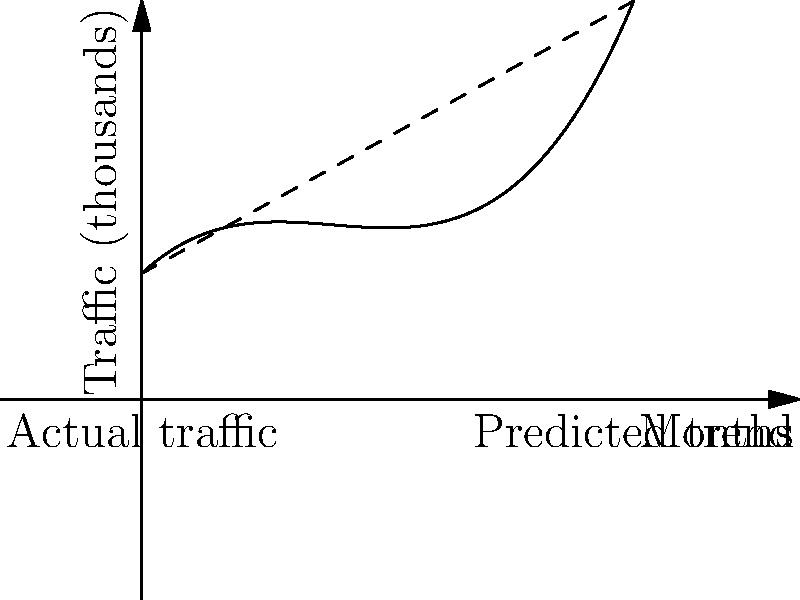Your e-commerce website's monthly traffic (in thousands) over the past year follows the polynomial function $f(x) = 0.5x^3 - 7x^2 + 30x + 100$, where $x$ represents the number of months since the start of the year. Based on this trend, what is the predicted traffic (rounded to the nearest thousand) for the 15th month? To solve this problem, we'll follow these steps:

1) We have the polynomial function: $f(x) = 0.5x^3 - 7x^2 + 30x + 100$

2) We need to calculate $f(15)$ as we want to predict the traffic for the 15th month.

3) Let's substitute $x = 15$ into the function:

   $f(15) = 0.5(15)^3 - 7(15)^2 + 30(15) + 100$

4) Now, let's calculate each term:
   - $0.5(15)^3 = 0.5 * 3375 = 1687.5$
   - $7(15)^2 = 7 * 225 = 1575$
   - $30(15) = 450$
   - The constant term is 100

5) Adding these up:
   $1687.5 - 1575 + 450 + 100 = 662.5$

6) Rounding to the nearest thousand:
   662.5 rounds to 663 thousand

Therefore, the predicted traffic for the 15th month is 663 thousand visitors.
Answer: 663 thousand 